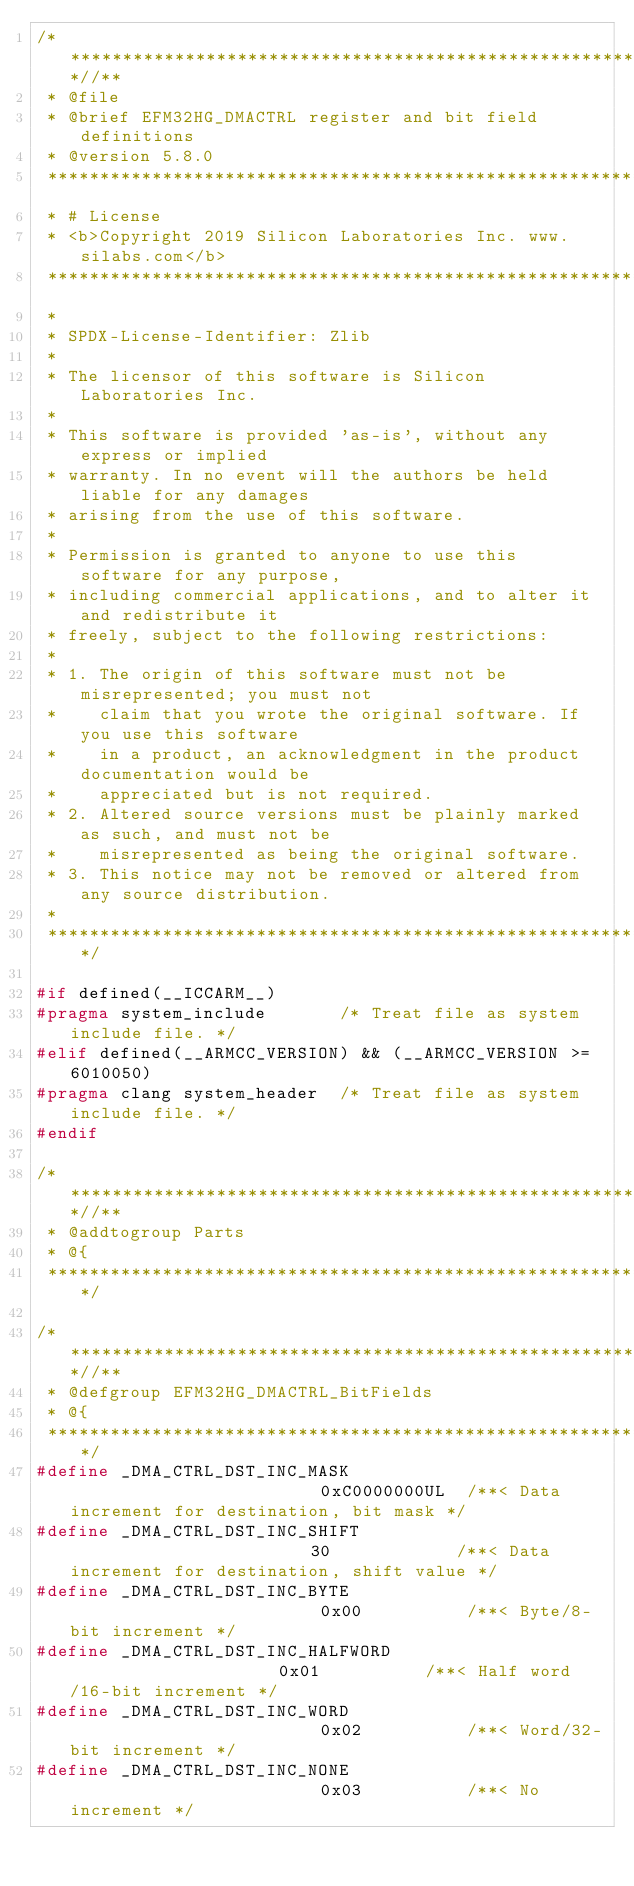Convert code to text. <code><loc_0><loc_0><loc_500><loc_500><_C_>/***************************************************************************//**
 * @file
 * @brief EFM32HG_DMACTRL register and bit field definitions
 * @version 5.8.0
 *******************************************************************************
 * # License
 * <b>Copyright 2019 Silicon Laboratories Inc. www.silabs.com</b>
 *******************************************************************************
 *
 * SPDX-License-Identifier: Zlib
 *
 * The licensor of this software is Silicon Laboratories Inc.
 *
 * This software is provided 'as-is', without any express or implied
 * warranty. In no event will the authors be held liable for any damages
 * arising from the use of this software.
 *
 * Permission is granted to anyone to use this software for any purpose,
 * including commercial applications, and to alter it and redistribute it
 * freely, subject to the following restrictions:
 *
 * 1. The origin of this software must not be misrepresented; you must not
 *    claim that you wrote the original software. If you use this software
 *    in a product, an acknowledgment in the product documentation would be
 *    appreciated but is not required.
 * 2. Altered source versions must be plainly marked as such, and must not be
 *    misrepresented as being the original software.
 * 3. This notice may not be removed or altered from any source distribution.
 *
 ******************************************************************************/

#if defined(__ICCARM__)
#pragma system_include       /* Treat file as system include file. */
#elif defined(__ARMCC_VERSION) && (__ARMCC_VERSION >= 6010050)
#pragma clang system_header  /* Treat file as system include file. */
#endif

/***************************************************************************//**
 * @addtogroup Parts
 * @{
 ******************************************************************************/

/***************************************************************************//**
 * @defgroup EFM32HG_DMACTRL_BitFields
 * @{
 ******************************************************************************/
#define _DMA_CTRL_DST_INC_MASK                         0xC0000000UL  /**< Data increment for destination, bit mask */
#define _DMA_CTRL_DST_INC_SHIFT                        30            /**< Data increment for destination, shift value */
#define _DMA_CTRL_DST_INC_BYTE                         0x00          /**< Byte/8-bit increment */
#define _DMA_CTRL_DST_INC_HALFWORD                     0x01          /**< Half word/16-bit increment */
#define _DMA_CTRL_DST_INC_WORD                         0x02          /**< Word/32-bit increment */
#define _DMA_CTRL_DST_INC_NONE                         0x03          /**< No increment */</code> 